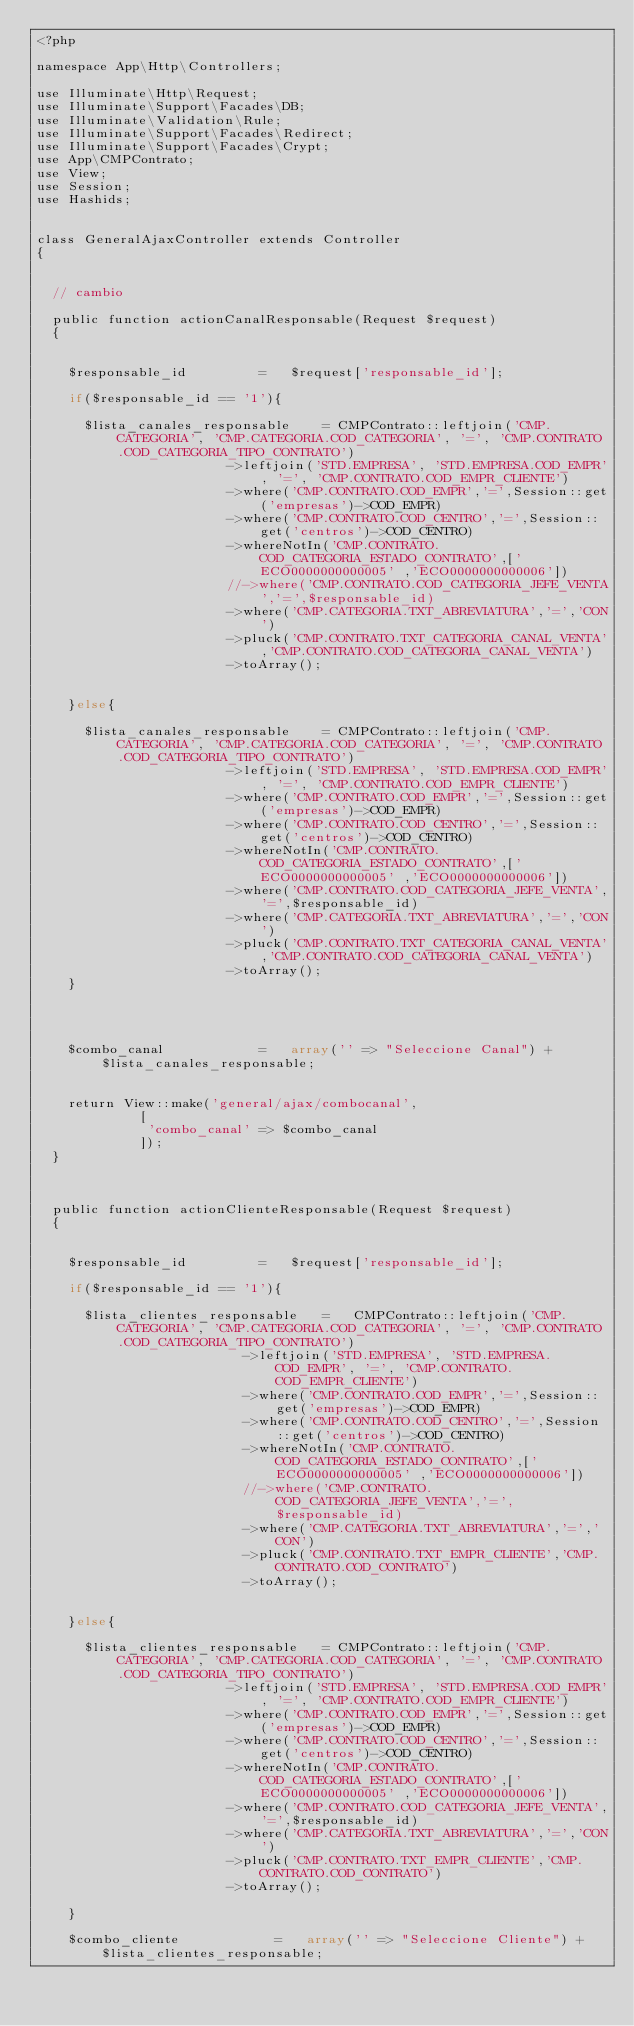Convert code to text. <code><loc_0><loc_0><loc_500><loc_500><_PHP_><?php

namespace App\Http\Controllers;

use Illuminate\Http\Request;
use Illuminate\Support\Facades\DB;
use Illuminate\Validation\Rule;
use Illuminate\Support\Facades\Redirect;
use Illuminate\Support\Facades\Crypt;
use App\CMPContrato;
use View;
use Session;
use Hashids;


class GeneralAjaxController extends Controller
{


	// cambio

	public function actionCanalResponsable(Request $request)
	{


		$responsable_id					= 	$request['responsable_id'];

		if($responsable_id == '1'){

			$lista_canales_responsable		=	CMPContrato::leftjoin('CMP.CATEGORIA', 'CMP.CATEGORIA.COD_CATEGORIA', '=', 'CMP.CONTRATO.COD_CATEGORIA_TIPO_CONTRATO')
												->leftjoin('STD.EMPRESA', 'STD.EMPRESA.COD_EMPR', '=', 'CMP.CONTRATO.COD_EMPR_CLIENTE')
												->where('CMP.CONTRATO.COD_EMPR','=',Session::get('empresas')->COD_EMPR)
												->where('CMP.CONTRATO.COD_CENTRO','=',Session::get('centros')->COD_CENTRO)
												->whereNotIn('CMP.CONTRATO.COD_CATEGORIA_ESTADO_CONTRATO',['ECO0000000000005' ,'ECO0000000000006'])
												//->where('CMP.CONTRATO.COD_CATEGORIA_JEFE_VENTA','=',$responsable_id)
												->where('CMP.CATEGORIA.TXT_ABREVIATURA','=','CON')
												->pluck('CMP.CONTRATO.TXT_CATEGORIA_CANAL_VENTA','CMP.CONTRATO.COD_CATEGORIA_CANAL_VENTA')
												->toArray();
									

		}else{

			$lista_canales_responsable		=	CMPContrato::leftjoin('CMP.CATEGORIA', 'CMP.CATEGORIA.COD_CATEGORIA', '=', 'CMP.CONTRATO.COD_CATEGORIA_TIPO_CONTRATO')
												->leftjoin('STD.EMPRESA', 'STD.EMPRESA.COD_EMPR', '=', 'CMP.CONTRATO.COD_EMPR_CLIENTE')
												->where('CMP.CONTRATO.COD_EMPR','=',Session::get('empresas')->COD_EMPR)
												->where('CMP.CONTRATO.COD_CENTRO','=',Session::get('centros')->COD_CENTRO)
												->whereNotIn('CMP.CONTRATO.COD_CATEGORIA_ESTADO_CONTRATO',['ECO0000000000005' ,'ECO0000000000006'])
												->where('CMP.CONTRATO.COD_CATEGORIA_JEFE_VENTA','=',$responsable_id)
												->where('CMP.CATEGORIA.TXT_ABREVIATURA','=','CON')
												->pluck('CMP.CONTRATO.TXT_CATEGORIA_CANAL_VENTA','CMP.CONTRATO.COD_CATEGORIA_CANAL_VENTA')
												->toArray();	
		}



							   
		$combo_canal  					= 	array('' => "Seleccione Canal") + $lista_canales_responsable;


		return View::make('general/ajax/combocanal',
						 [
						 	'combo_canal' => $combo_canal
						 ]);
	}	



	public function actionClienteResponsable(Request $request)
	{


		$responsable_id					= 	$request['responsable_id'];

		if($responsable_id == '1'){

			$lista_clientes_responsable		=		CMPContrato::leftjoin('CMP.CATEGORIA', 'CMP.CATEGORIA.COD_CATEGORIA', '=', 'CMP.CONTRATO.COD_CATEGORIA_TIPO_CONTRATO')
													->leftjoin('STD.EMPRESA', 'STD.EMPRESA.COD_EMPR', '=', 'CMP.CONTRATO.COD_EMPR_CLIENTE')
													->where('CMP.CONTRATO.COD_EMPR','=',Session::get('empresas')->COD_EMPR)
													->where('CMP.CONTRATO.COD_CENTRO','=',Session::get('centros')->COD_CENTRO)
													->whereNotIn('CMP.CONTRATO.COD_CATEGORIA_ESTADO_CONTRATO',['ECO0000000000005' ,'ECO0000000000006'])
													//->where('CMP.CONTRATO.COD_CATEGORIA_JEFE_VENTA','=',$responsable_id)
													->where('CMP.CATEGORIA.TXT_ABREVIATURA','=','CON')
													->pluck('CMP.CONTRATO.TXT_EMPR_CLIENTE','CMP.CONTRATO.COD_CONTRATO')
													->toArray();
									

		}else{

			$lista_clientes_responsable		=	CMPContrato::leftjoin('CMP.CATEGORIA', 'CMP.CATEGORIA.COD_CATEGORIA', '=', 'CMP.CONTRATO.COD_CATEGORIA_TIPO_CONTRATO')
												->leftjoin('STD.EMPRESA', 'STD.EMPRESA.COD_EMPR', '=', 'CMP.CONTRATO.COD_EMPR_CLIENTE')
												->where('CMP.CONTRATO.COD_EMPR','=',Session::get('empresas')->COD_EMPR)
												->where('CMP.CONTRATO.COD_CENTRO','=',Session::get('centros')->COD_CENTRO)
												->whereNotIn('CMP.CONTRATO.COD_CATEGORIA_ESTADO_CONTRATO',['ECO0000000000005' ,'ECO0000000000006'])
												->where('CMP.CONTRATO.COD_CATEGORIA_JEFE_VENTA','=',$responsable_id)
												->where('CMP.CATEGORIA.TXT_ABREVIATURA','=','CON')
												->pluck('CMP.CONTRATO.TXT_EMPR_CLIENTE','CMP.CONTRATO.COD_CONTRATO')
												->toArray();
						
		}

		$combo_cliente  					= 	array('' => "Seleccione Cliente") + $lista_clientes_responsable;

</code> 